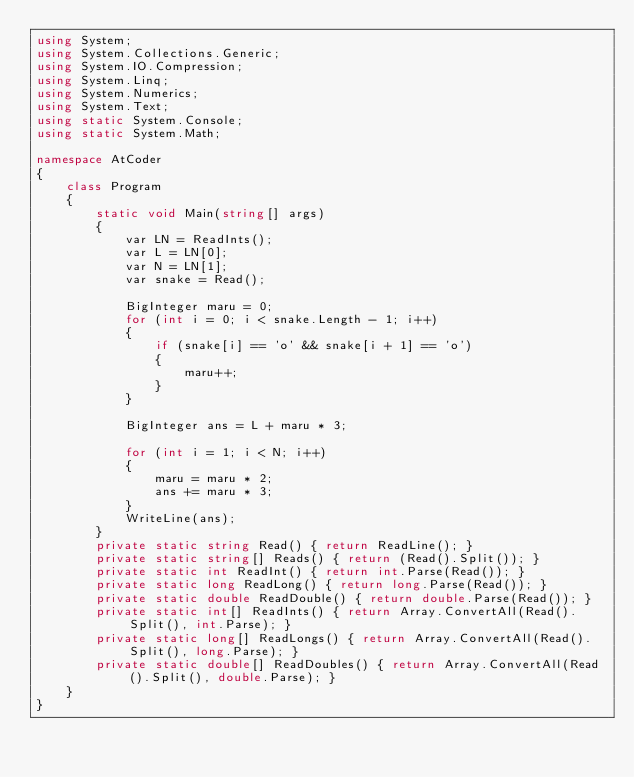<code> <loc_0><loc_0><loc_500><loc_500><_C#_>using System;
using System.Collections.Generic;
using System.IO.Compression;
using System.Linq;
using System.Numerics;
using System.Text;
using static System.Console;
using static System.Math;

namespace AtCoder
{
    class Program
    {
        static void Main(string[] args)
        {
            var LN = ReadInts();
            var L = LN[0];
            var N = LN[1];
            var snake = Read();

            BigInteger maru = 0;
            for (int i = 0; i < snake.Length - 1; i++)
            {
                if (snake[i] == 'o' && snake[i + 1] == 'o')
                {
                    maru++;
                }
            }

            BigInteger ans = L + maru * 3;

            for (int i = 1; i < N; i++)
            {
                maru = maru * 2;
                ans += maru * 3;
            }
            WriteLine(ans);
        }
        private static string Read() { return ReadLine(); }
        private static string[] Reads() { return (Read().Split()); }
        private static int ReadInt() { return int.Parse(Read()); }
        private static long ReadLong() { return long.Parse(Read()); }
        private static double ReadDouble() { return double.Parse(Read()); }
        private static int[] ReadInts() { return Array.ConvertAll(Read().Split(), int.Parse); }
        private static long[] ReadLongs() { return Array.ConvertAll(Read().Split(), long.Parse); }
        private static double[] ReadDoubles() { return Array.ConvertAll(Read().Split(), double.Parse); }
    }
}

</code> 